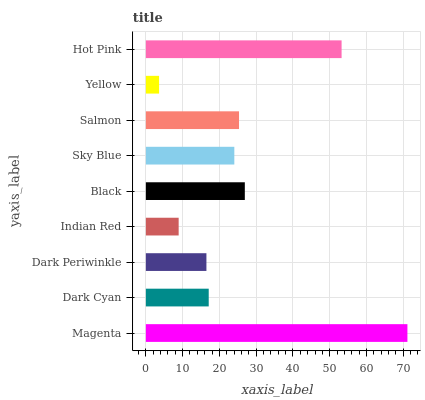Is Yellow the minimum?
Answer yes or no. Yes. Is Magenta the maximum?
Answer yes or no. Yes. Is Dark Cyan the minimum?
Answer yes or no. No. Is Dark Cyan the maximum?
Answer yes or no. No. Is Magenta greater than Dark Cyan?
Answer yes or no. Yes. Is Dark Cyan less than Magenta?
Answer yes or no. Yes. Is Dark Cyan greater than Magenta?
Answer yes or no. No. Is Magenta less than Dark Cyan?
Answer yes or no. No. Is Sky Blue the high median?
Answer yes or no. Yes. Is Sky Blue the low median?
Answer yes or no. Yes. Is Yellow the high median?
Answer yes or no. No. Is Magenta the low median?
Answer yes or no. No. 